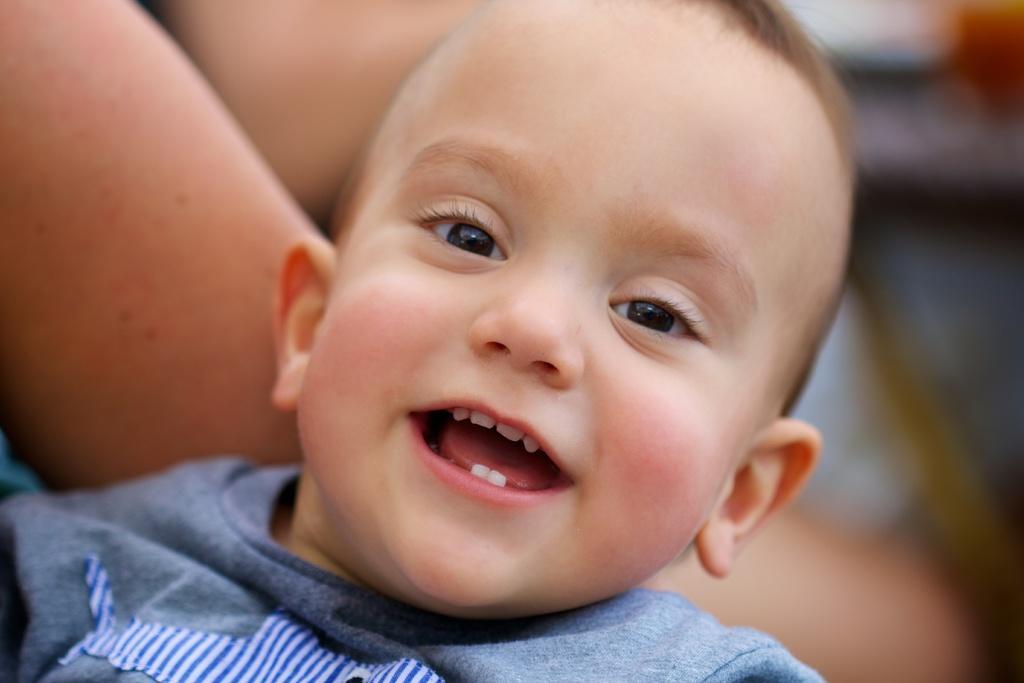Could you give a brief overview of what you see in this image? In this image we can see few people. There is a blur background at the right side of the image. 